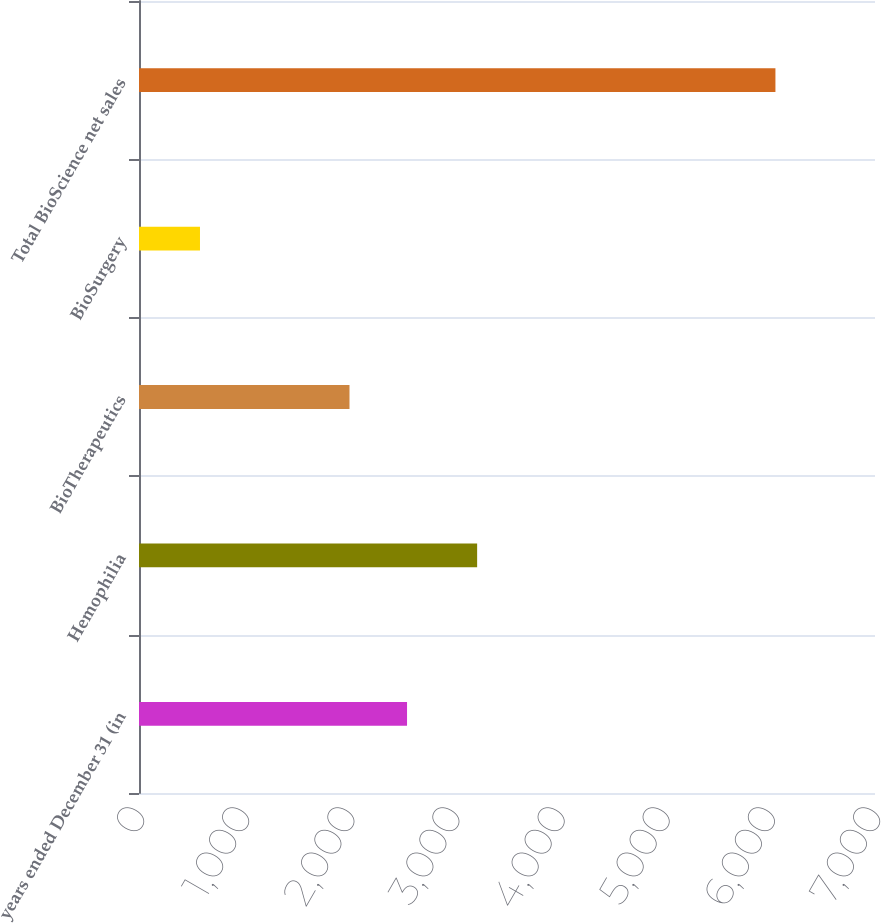Convert chart. <chart><loc_0><loc_0><loc_500><loc_500><bar_chart><fcel>years ended December 31 (in<fcel>Hemophilia<fcel>BioTherapeutics<fcel>BioSurgery<fcel>Total BioScience net sales<nl><fcel>2549.3<fcel>3216<fcel>2002<fcel>580<fcel>6053<nl></chart> 